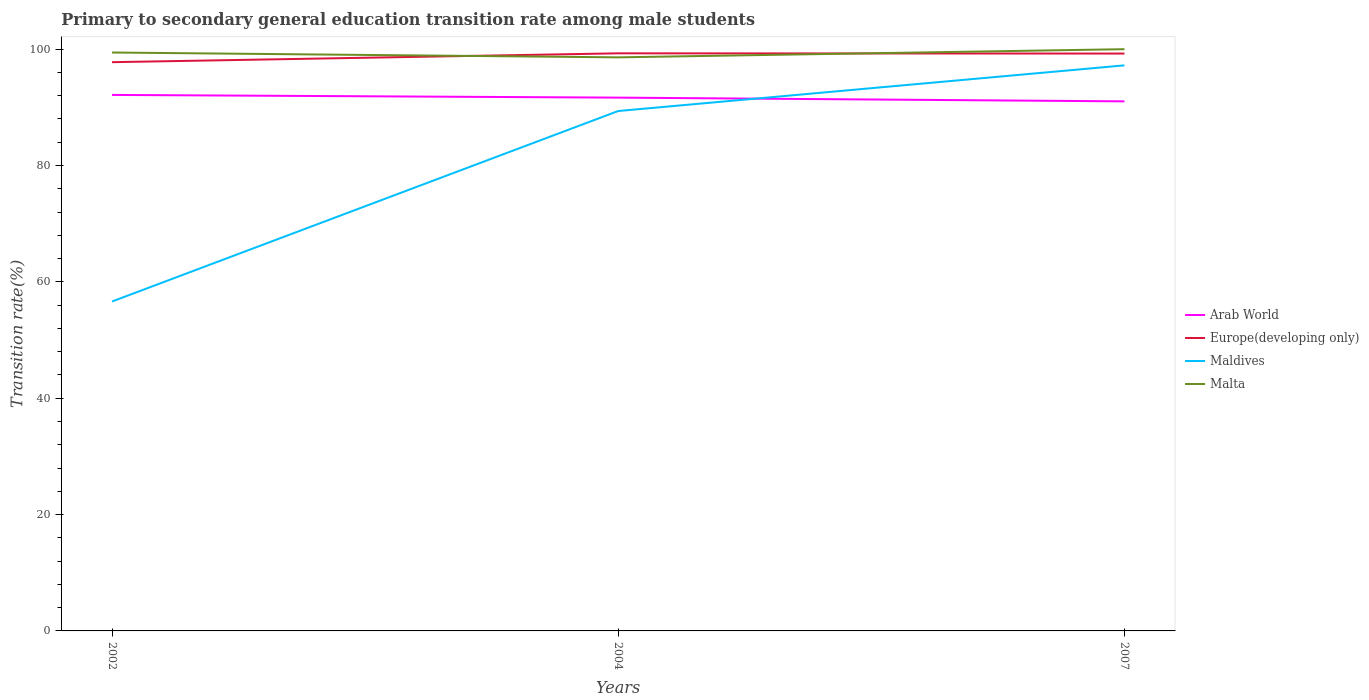Across all years, what is the maximum transition rate in Europe(developing only)?
Offer a very short reply. 97.77. In which year was the transition rate in Arab World maximum?
Make the answer very short. 2007. What is the total transition rate in Maldives in the graph?
Ensure brevity in your answer.  -7.85. What is the difference between the highest and the second highest transition rate in Europe(developing only)?
Offer a very short reply. 1.52. What is the difference between the highest and the lowest transition rate in Europe(developing only)?
Make the answer very short. 2. Is the transition rate in Europe(developing only) strictly greater than the transition rate in Malta over the years?
Offer a very short reply. No. What is the difference between two consecutive major ticks on the Y-axis?
Your response must be concise. 20. Are the values on the major ticks of Y-axis written in scientific E-notation?
Offer a very short reply. No. Does the graph contain grids?
Provide a short and direct response. No. Where does the legend appear in the graph?
Your response must be concise. Center right. How many legend labels are there?
Keep it short and to the point. 4. How are the legend labels stacked?
Your answer should be very brief. Vertical. What is the title of the graph?
Keep it short and to the point. Primary to secondary general education transition rate among male students. Does "Oman" appear as one of the legend labels in the graph?
Ensure brevity in your answer.  No. What is the label or title of the X-axis?
Provide a succinct answer. Years. What is the label or title of the Y-axis?
Give a very brief answer. Transition rate(%). What is the Transition rate(%) of Arab World in 2002?
Your response must be concise. 92.14. What is the Transition rate(%) of Europe(developing only) in 2002?
Provide a short and direct response. 97.77. What is the Transition rate(%) in Maldives in 2002?
Make the answer very short. 56.63. What is the Transition rate(%) in Malta in 2002?
Make the answer very short. 99.43. What is the Transition rate(%) of Arab World in 2004?
Give a very brief answer. 91.67. What is the Transition rate(%) in Europe(developing only) in 2004?
Keep it short and to the point. 99.29. What is the Transition rate(%) of Maldives in 2004?
Offer a very short reply. 89.37. What is the Transition rate(%) in Malta in 2004?
Give a very brief answer. 98.6. What is the Transition rate(%) in Arab World in 2007?
Make the answer very short. 91.03. What is the Transition rate(%) of Europe(developing only) in 2007?
Offer a terse response. 99.25. What is the Transition rate(%) of Maldives in 2007?
Ensure brevity in your answer.  97.22. Across all years, what is the maximum Transition rate(%) of Arab World?
Keep it short and to the point. 92.14. Across all years, what is the maximum Transition rate(%) in Europe(developing only)?
Your response must be concise. 99.29. Across all years, what is the maximum Transition rate(%) in Maldives?
Make the answer very short. 97.22. Across all years, what is the minimum Transition rate(%) in Arab World?
Provide a short and direct response. 91.03. Across all years, what is the minimum Transition rate(%) in Europe(developing only)?
Provide a short and direct response. 97.77. Across all years, what is the minimum Transition rate(%) of Maldives?
Your answer should be compact. 56.63. Across all years, what is the minimum Transition rate(%) of Malta?
Keep it short and to the point. 98.6. What is the total Transition rate(%) of Arab World in the graph?
Offer a terse response. 274.84. What is the total Transition rate(%) of Europe(developing only) in the graph?
Give a very brief answer. 296.3. What is the total Transition rate(%) of Maldives in the graph?
Provide a short and direct response. 243.22. What is the total Transition rate(%) of Malta in the graph?
Your answer should be compact. 298.03. What is the difference between the Transition rate(%) of Arab World in 2002 and that in 2004?
Your answer should be very brief. 0.47. What is the difference between the Transition rate(%) in Europe(developing only) in 2002 and that in 2004?
Your answer should be compact. -1.52. What is the difference between the Transition rate(%) of Maldives in 2002 and that in 2004?
Provide a succinct answer. -32.74. What is the difference between the Transition rate(%) of Malta in 2002 and that in 2004?
Your response must be concise. 0.83. What is the difference between the Transition rate(%) of Arab World in 2002 and that in 2007?
Provide a short and direct response. 1.11. What is the difference between the Transition rate(%) of Europe(developing only) in 2002 and that in 2007?
Offer a terse response. -1.48. What is the difference between the Transition rate(%) in Maldives in 2002 and that in 2007?
Provide a short and direct response. -40.59. What is the difference between the Transition rate(%) in Malta in 2002 and that in 2007?
Your answer should be very brief. -0.57. What is the difference between the Transition rate(%) of Arab World in 2004 and that in 2007?
Your answer should be compact. 0.64. What is the difference between the Transition rate(%) in Europe(developing only) in 2004 and that in 2007?
Your answer should be very brief. 0.04. What is the difference between the Transition rate(%) of Maldives in 2004 and that in 2007?
Your response must be concise. -7.85. What is the difference between the Transition rate(%) in Malta in 2004 and that in 2007?
Offer a very short reply. -1.4. What is the difference between the Transition rate(%) in Arab World in 2002 and the Transition rate(%) in Europe(developing only) in 2004?
Provide a short and direct response. -7.15. What is the difference between the Transition rate(%) in Arab World in 2002 and the Transition rate(%) in Maldives in 2004?
Your answer should be very brief. 2.77. What is the difference between the Transition rate(%) of Arab World in 2002 and the Transition rate(%) of Malta in 2004?
Your response must be concise. -6.46. What is the difference between the Transition rate(%) of Europe(developing only) in 2002 and the Transition rate(%) of Maldives in 2004?
Offer a very short reply. 8.4. What is the difference between the Transition rate(%) of Europe(developing only) in 2002 and the Transition rate(%) of Malta in 2004?
Your answer should be very brief. -0.83. What is the difference between the Transition rate(%) in Maldives in 2002 and the Transition rate(%) in Malta in 2004?
Provide a succinct answer. -41.97. What is the difference between the Transition rate(%) in Arab World in 2002 and the Transition rate(%) in Europe(developing only) in 2007?
Your response must be concise. -7.11. What is the difference between the Transition rate(%) in Arab World in 2002 and the Transition rate(%) in Maldives in 2007?
Provide a succinct answer. -5.08. What is the difference between the Transition rate(%) in Arab World in 2002 and the Transition rate(%) in Malta in 2007?
Offer a terse response. -7.86. What is the difference between the Transition rate(%) in Europe(developing only) in 2002 and the Transition rate(%) in Maldives in 2007?
Provide a short and direct response. 0.55. What is the difference between the Transition rate(%) of Europe(developing only) in 2002 and the Transition rate(%) of Malta in 2007?
Give a very brief answer. -2.23. What is the difference between the Transition rate(%) of Maldives in 2002 and the Transition rate(%) of Malta in 2007?
Your response must be concise. -43.37. What is the difference between the Transition rate(%) in Arab World in 2004 and the Transition rate(%) in Europe(developing only) in 2007?
Your response must be concise. -7.57. What is the difference between the Transition rate(%) in Arab World in 2004 and the Transition rate(%) in Maldives in 2007?
Offer a very short reply. -5.55. What is the difference between the Transition rate(%) in Arab World in 2004 and the Transition rate(%) in Malta in 2007?
Ensure brevity in your answer.  -8.33. What is the difference between the Transition rate(%) in Europe(developing only) in 2004 and the Transition rate(%) in Maldives in 2007?
Offer a very short reply. 2.07. What is the difference between the Transition rate(%) in Europe(developing only) in 2004 and the Transition rate(%) in Malta in 2007?
Offer a terse response. -0.71. What is the difference between the Transition rate(%) in Maldives in 2004 and the Transition rate(%) in Malta in 2007?
Keep it short and to the point. -10.63. What is the average Transition rate(%) of Arab World per year?
Make the answer very short. 91.61. What is the average Transition rate(%) of Europe(developing only) per year?
Ensure brevity in your answer.  98.77. What is the average Transition rate(%) in Maldives per year?
Your answer should be very brief. 81.07. What is the average Transition rate(%) of Malta per year?
Keep it short and to the point. 99.34. In the year 2002, what is the difference between the Transition rate(%) of Arab World and Transition rate(%) of Europe(developing only)?
Give a very brief answer. -5.63. In the year 2002, what is the difference between the Transition rate(%) in Arab World and Transition rate(%) in Maldives?
Give a very brief answer. 35.51. In the year 2002, what is the difference between the Transition rate(%) of Arab World and Transition rate(%) of Malta?
Give a very brief answer. -7.29. In the year 2002, what is the difference between the Transition rate(%) in Europe(developing only) and Transition rate(%) in Maldives?
Offer a terse response. 41.14. In the year 2002, what is the difference between the Transition rate(%) in Europe(developing only) and Transition rate(%) in Malta?
Your answer should be very brief. -1.66. In the year 2002, what is the difference between the Transition rate(%) of Maldives and Transition rate(%) of Malta?
Your answer should be very brief. -42.8. In the year 2004, what is the difference between the Transition rate(%) of Arab World and Transition rate(%) of Europe(developing only)?
Your answer should be compact. -7.61. In the year 2004, what is the difference between the Transition rate(%) in Arab World and Transition rate(%) in Maldives?
Provide a succinct answer. 2.3. In the year 2004, what is the difference between the Transition rate(%) of Arab World and Transition rate(%) of Malta?
Your answer should be very brief. -6.92. In the year 2004, what is the difference between the Transition rate(%) of Europe(developing only) and Transition rate(%) of Maldives?
Offer a very short reply. 9.92. In the year 2004, what is the difference between the Transition rate(%) in Europe(developing only) and Transition rate(%) in Malta?
Your answer should be very brief. 0.69. In the year 2004, what is the difference between the Transition rate(%) of Maldives and Transition rate(%) of Malta?
Ensure brevity in your answer.  -9.23. In the year 2007, what is the difference between the Transition rate(%) in Arab World and Transition rate(%) in Europe(developing only)?
Keep it short and to the point. -8.22. In the year 2007, what is the difference between the Transition rate(%) in Arab World and Transition rate(%) in Maldives?
Your answer should be compact. -6.19. In the year 2007, what is the difference between the Transition rate(%) of Arab World and Transition rate(%) of Malta?
Offer a very short reply. -8.97. In the year 2007, what is the difference between the Transition rate(%) of Europe(developing only) and Transition rate(%) of Maldives?
Offer a terse response. 2.03. In the year 2007, what is the difference between the Transition rate(%) of Europe(developing only) and Transition rate(%) of Malta?
Make the answer very short. -0.75. In the year 2007, what is the difference between the Transition rate(%) of Maldives and Transition rate(%) of Malta?
Give a very brief answer. -2.78. What is the ratio of the Transition rate(%) of Arab World in 2002 to that in 2004?
Your answer should be compact. 1.01. What is the ratio of the Transition rate(%) in Europe(developing only) in 2002 to that in 2004?
Your response must be concise. 0.98. What is the ratio of the Transition rate(%) of Maldives in 2002 to that in 2004?
Give a very brief answer. 0.63. What is the ratio of the Transition rate(%) of Malta in 2002 to that in 2004?
Offer a terse response. 1.01. What is the ratio of the Transition rate(%) in Arab World in 2002 to that in 2007?
Your answer should be compact. 1.01. What is the ratio of the Transition rate(%) in Europe(developing only) in 2002 to that in 2007?
Provide a succinct answer. 0.99. What is the ratio of the Transition rate(%) in Maldives in 2002 to that in 2007?
Make the answer very short. 0.58. What is the ratio of the Transition rate(%) in Arab World in 2004 to that in 2007?
Make the answer very short. 1.01. What is the ratio of the Transition rate(%) in Maldives in 2004 to that in 2007?
Your answer should be compact. 0.92. What is the ratio of the Transition rate(%) of Malta in 2004 to that in 2007?
Ensure brevity in your answer.  0.99. What is the difference between the highest and the second highest Transition rate(%) of Arab World?
Offer a terse response. 0.47. What is the difference between the highest and the second highest Transition rate(%) in Europe(developing only)?
Provide a succinct answer. 0.04. What is the difference between the highest and the second highest Transition rate(%) in Maldives?
Your response must be concise. 7.85. What is the difference between the highest and the second highest Transition rate(%) in Malta?
Offer a terse response. 0.57. What is the difference between the highest and the lowest Transition rate(%) of Arab World?
Your answer should be very brief. 1.11. What is the difference between the highest and the lowest Transition rate(%) in Europe(developing only)?
Your answer should be compact. 1.52. What is the difference between the highest and the lowest Transition rate(%) of Maldives?
Offer a terse response. 40.59. What is the difference between the highest and the lowest Transition rate(%) of Malta?
Your answer should be compact. 1.4. 